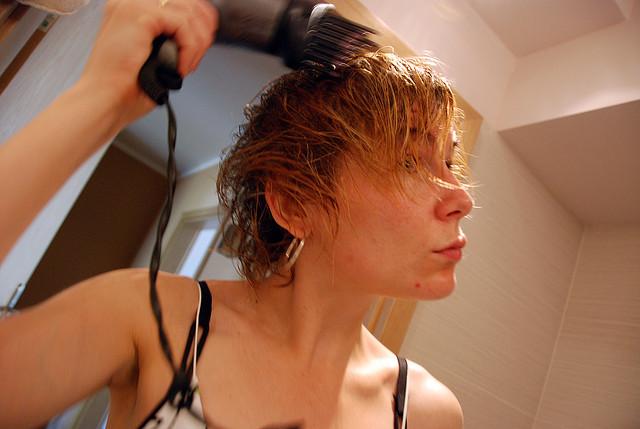What color is the woman's hair?
Concise answer only. Blonde. What is this woman doing?
Keep it brief. Drying her hair. Is the woman's hair wet?
Keep it brief. Yes. 